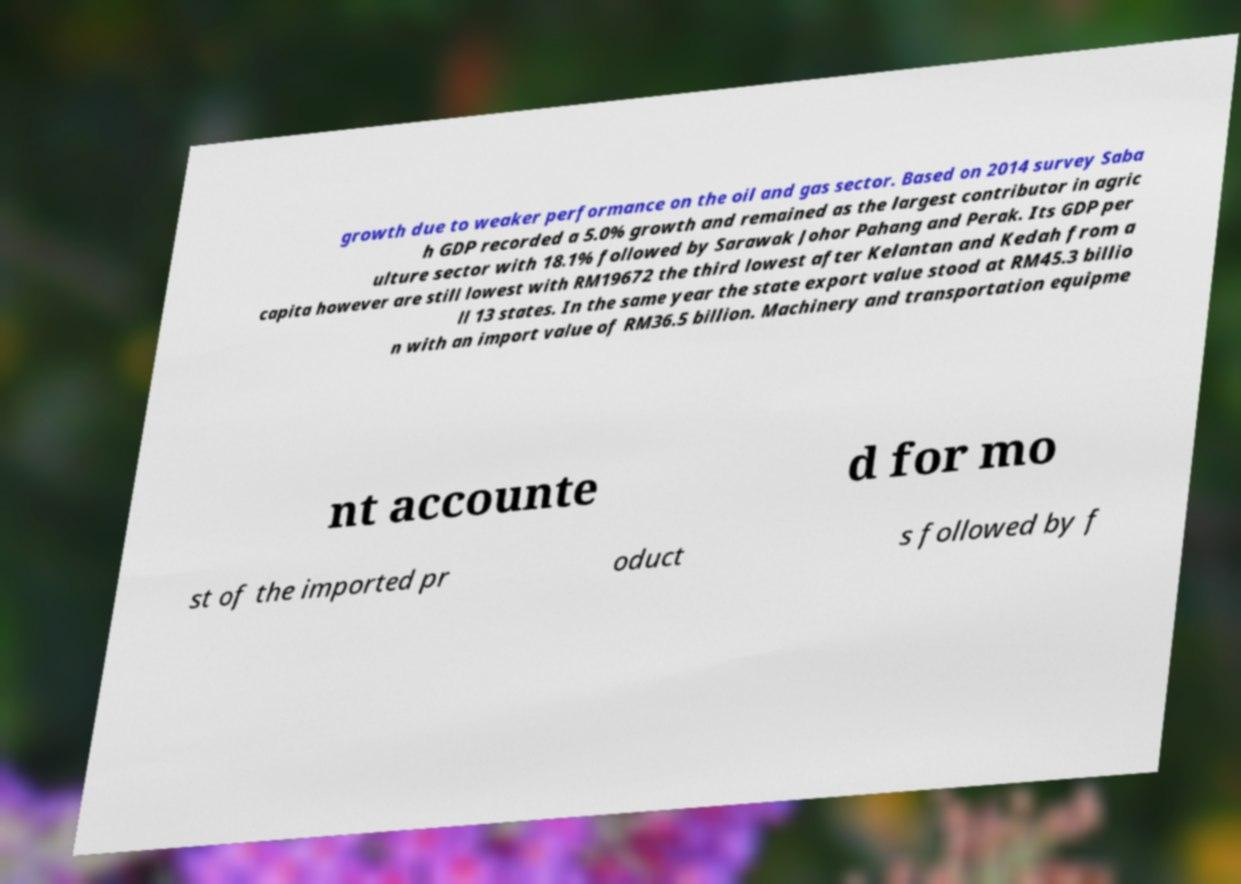Please identify and transcribe the text found in this image. growth due to weaker performance on the oil and gas sector. Based on 2014 survey Saba h GDP recorded a 5.0% growth and remained as the largest contributor in agric ulture sector with 18.1% followed by Sarawak Johor Pahang and Perak. Its GDP per capita however are still lowest with RM19672 the third lowest after Kelantan and Kedah from a ll 13 states. In the same year the state export value stood at RM45.3 billio n with an import value of RM36.5 billion. Machinery and transportation equipme nt accounte d for mo st of the imported pr oduct s followed by f 